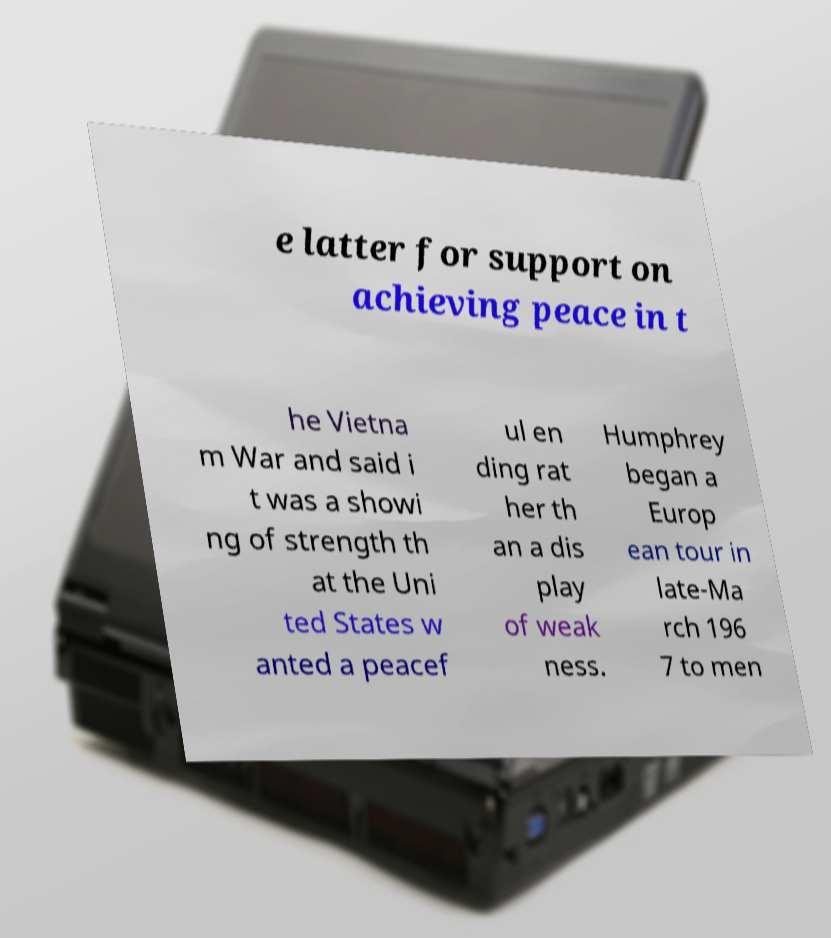Could you extract and type out the text from this image? e latter for support on achieving peace in t he Vietna m War and said i t was a showi ng of strength th at the Uni ted States w anted a peacef ul en ding rat her th an a dis play of weak ness. Humphrey began a Europ ean tour in late-Ma rch 196 7 to men 